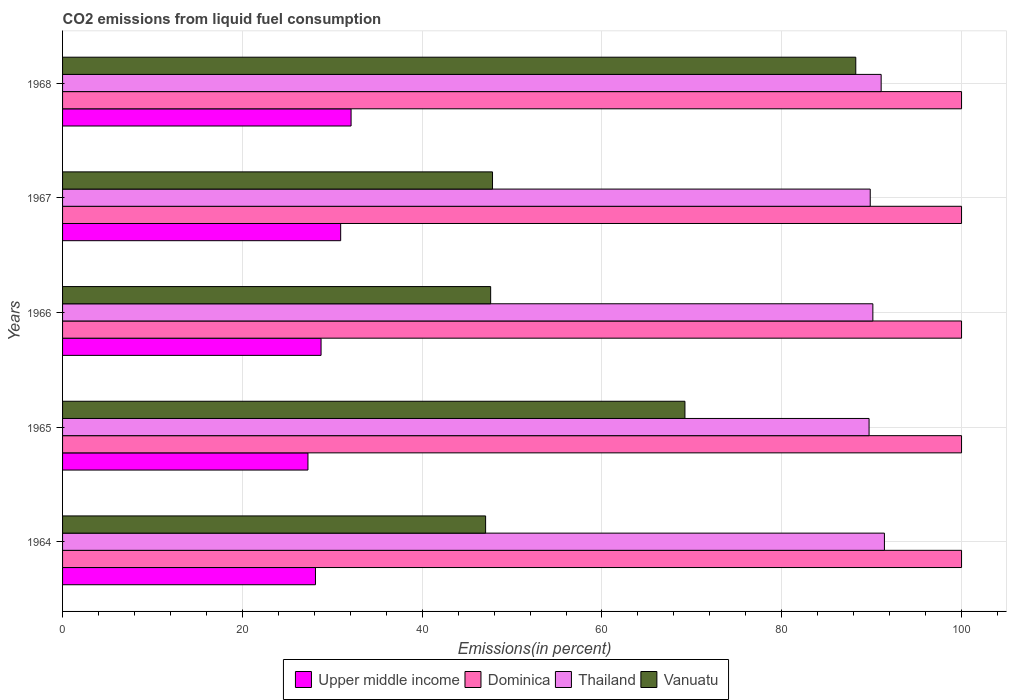Are the number of bars per tick equal to the number of legend labels?
Your response must be concise. Yes. How many bars are there on the 3rd tick from the bottom?
Offer a terse response. 4. What is the label of the 2nd group of bars from the top?
Make the answer very short. 1967. In how many cases, is the number of bars for a given year not equal to the number of legend labels?
Keep it short and to the point. 0. What is the total CO2 emitted in Upper middle income in 1968?
Offer a very short reply. 32.09. Across all years, what is the maximum total CO2 emitted in Upper middle income?
Your answer should be very brief. 32.09. Across all years, what is the minimum total CO2 emitted in Dominica?
Your answer should be compact. 100. In which year was the total CO2 emitted in Dominica maximum?
Provide a succinct answer. 1964. In which year was the total CO2 emitted in Dominica minimum?
Offer a very short reply. 1964. What is the total total CO2 emitted in Thailand in the graph?
Give a very brief answer. 452.17. What is the difference between the total CO2 emitted in Upper middle income in 1966 and that in 1967?
Provide a succinct answer. -2.18. What is the difference between the total CO2 emitted in Vanuatu in 1966 and the total CO2 emitted in Thailand in 1967?
Give a very brief answer. -42.22. What is the average total CO2 emitted in Dominica per year?
Provide a succinct answer. 100. In the year 1966, what is the difference between the total CO2 emitted in Thailand and total CO2 emitted in Dominica?
Keep it short and to the point. -9.86. What is the ratio of the total CO2 emitted in Thailand in 1965 to that in 1966?
Offer a terse response. 1. Is the total CO2 emitted in Dominica in 1964 less than that in 1968?
Your response must be concise. No. Is the difference between the total CO2 emitted in Thailand in 1964 and 1967 greater than the difference between the total CO2 emitted in Dominica in 1964 and 1967?
Give a very brief answer. Yes. What is the difference between the highest and the second highest total CO2 emitted in Upper middle income?
Provide a short and direct response. 1.16. What is the difference between the highest and the lowest total CO2 emitted in Thailand?
Provide a succinct answer. 1.71. What does the 4th bar from the top in 1965 represents?
Your answer should be very brief. Upper middle income. What does the 4th bar from the bottom in 1964 represents?
Provide a short and direct response. Vanuatu. Is it the case that in every year, the sum of the total CO2 emitted in Thailand and total CO2 emitted in Vanuatu is greater than the total CO2 emitted in Upper middle income?
Offer a very short reply. Yes. Are all the bars in the graph horizontal?
Provide a succinct answer. Yes. Are the values on the major ticks of X-axis written in scientific E-notation?
Make the answer very short. No. Does the graph contain any zero values?
Make the answer very short. No. Does the graph contain grids?
Provide a succinct answer. Yes. Where does the legend appear in the graph?
Provide a short and direct response. Bottom center. How many legend labels are there?
Offer a terse response. 4. How are the legend labels stacked?
Offer a very short reply. Horizontal. What is the title of the graph?
Keep it short and to the point. CO2 emissions from liquid fuel consumption. What is the label or title of the X-axis?
Provide a short and direct response. Emissions(in percent). What is the Emissions(in percent) in Upper middle income in 1964?
Offer a very short reply. 28.13. What is the Emissions(in percent) in Thailand in 1964?
Provide a succinct answer. 91.42. What is the Emissions(in percent) in Vanuatu in 1964?
Make the answer very short. 47.06. What is the Emissions(in percent) of Upper middle income in 1965?
Keep it short and to the point. 27.3. What is the Emissions(in percent) of Dominica in 1965?
Your answer should be compact. 100. What is the Emissions(in percent) of Thailand in 1965?
Make the answer very short. 89.71. What is the Emissions(in percent) of Vanuatu in 1965?
Ensure brevity in your answer.  69.23. What is the Emissions(in percent) of Upper middle income in 1966?
Your answer should be very brief. 28.75. What is the Emissions(in percent) of Dominica in 1966?
Provide a succinct answer. 100. What is the Emissions(in percent) of Thailand in 1966?
Provide a succinct answer. 90.14. What is the Emissions(in percent) of Vanuatu in 1966?
Provide a short and direct response. 47.62. What is the Emissions(in percent) of Upper middle income in 1967?
Provide a succinct answer. 30.94. What is the Emissions(in percent) of Thailand in 1967?
Give a very brief answer. 89.84. What is the Emissions(in percent) in Vanuatu in 1967?
Keep it short and to the point. 47.83. What is the Emissions(in percent) of Upper middle income in 1968?
Ensure brevity in your answer.  32.09. What is the Emissions(in percent) in Dominica in 1968?
Your response must be concise. 100. What is the Emissions(in percent) of Thailand in 1968?
Keep it short and to the point. 91.06. What is the Emissions(in percent) in Vanuatu in 1968?
Offer a terse response. 88.24. Across all years, what is the maximum Emissions(in percent) in Upper middle income?
Make the answer very short. 32.09. Across all years, what is the maximum Emissions(in percent) of Dominica?
Provide a succinct answer. 100. Across all years, what is the maximum Emissions(in percent) of Thailand?
Ensure brevity in your answer.  91.42. Across all years, what is the maximum Emissions(in percent) of Vanuatu?
Offer a very short reply. 88.24. Across all years, what is the minimum Emissions(in percent) in Upper middle income?
Provide a succinct answer. 27.3. Across all years, what is the minimum Emissions(in percent) in Thailand?
Your answer should be very brief. 89.71. Across all years, what is the minimum Emissions(in percent) of Vanuatu?
Ensure brevity in your answer.  47.06. What is the total Emissions(in percent) in Upper middle income in the graph?
Your answer should be compact. 147.21. What is the total Emissions(in percent) in Dominica in the graph?
Offer a very short reply. 500. What is the total Emissions(in percent) in Thailand in the graph?
Offer a very short reply. 452.17. What is the total Emissions(in percent) in Vanuatu in the graph?
Make the answer very short. 299.97. What is the difference between the Emissions(in percent) in Upper middle income in 1964 and that in 1965?
Your response must be concise. 0.84. What is the difference between the Emissions(in percent) of Thailand in 1964 and that in 1965?
Your answer should be very brief. 1.71. What is the difference between the Emissions(in percent) of Vanuatu in 1964 and that in 1965?
Give a very brief answer. -22.17. What is the difference between the Emissions(in percent) of Upper middle income in 1964 and that in 1966?
Give a very brief answer. -0.62. What is the difference between the Emissions(in percent) in Dominica in 1964 and that in 1966?
Provide a succinct answer. 0. What is the difference between the Emissions(in percent) in Thailand in 1964 and that in 1966?
Offer a very short reply. 1.29. What is the difference between the Emissions(in percent) in Vanuatu in 1964 and that in 1966?
Your answer should be very brief. -0.56. What is the difference between the Emissions(in percent) of Upper middle income in 1964 and that in 1967?
Make the answer very short. -2.8. What is the difference between the Emissions(in percent) of Dominica in 1964 and that in 1967?
Offer a very short reply. 0. What is the difference between the Emissions(in percent) of Thailand in 1964 and that in 1967?
Offer a very short reply. 1.58. What is the difference between the Emissions(in percent) of Vanuatu in 1964 and that in 1967?
Offer a terse response. -0.77. What is the difference between the Emissions(in percent) in Upper middle income in 1964 and that in 1968?
Give a very brief answer. -3.96. What is the difference between the Emissions(in percent) of Dominica in 1964 and that in 1968?
Ensure brevity in your answer.  0. What is the difference between the Emissions(in percent) in Thailand in 1964 and that in 1968?
Give a very brief answer. 0.36. What is the difference between the Emissions(in percent) in Vanuatu in 1964 and that in 1968?
Make the answer very short. -41.18. What is the difference between the Emissions(in percent) of Upper middle income in 1965 and that in 1966?
Ensure brevity in your answer.  -1.46. What is the difference between the Emissions(in percent) in Thailand in 1965 and that in 1966?
Provide a succinct answer. -0.42. What is the difference between the Emissions(in percent) in Vanuatu in 1965 and that in 1966?
Offer a terse response. 21.61. What is the difference between the Emissions(in percent) in Upper middle income in 1965 and that in 1967?
Provide a short and direct response. -3.64. What is the difference between the Emissions(in percent) in Dominica in 1965 and that in 1967?
Your response must be concise. 0. What is the difference between the Emissions(in percent) in Thailand in 1965 and that in 1967?
Make the answer very short. -0.13. What is the difference between the Emissions(in percent) of Vanuatu in 1965 and that in 1967?
Offer a terse response. 21.4. What is the difference between the Emissions(in percent) in Upper middle income in 1965 and that in 1968?
Your answer should be compact. -4.8. What is the difference between the Emissions(in percent) of Dominica in 1965 and that in 1968?
Provide a short and direct response. 0. What is the difference between the Emissions(in percent) in Thailand in 1965 and that in 1968?
Offer a very short reply. -1.34. What is the difference between the Emissions(in percent) in Vanuatu in 1965 and that in 1968?
Offer a very short reply. -19. What is the difference between the Emissions(in percent) of Upper middle income in 1966 and that in 1967?
Offer a very short reply. -2.18. What is the difference between the Emissions(in percent) of Dominica in 1966 and that in 1967?
Offer a very short reply. 0. What is the difference between the Emissions(in percent) in Thailand in 1966 and that in 1967?
Your response must be concise. 0.29. What is the difference between the Emissions(in percent) of Vanuatu in 1966 and that in 1967?
Provide a succinct answer. -0.21. What is the difference between the Emissions(in percent) in Upper middle income in 1966 and that in 1968?
Make the answer very short. -3.34. What is the difference between the Emissions(in percent) in Thailand in 1966 and that in 1968?
Ensure brevity in your answer.  -0.92. What is the difference between the Emissions(in percent) of Vanuatu in 1966 and that in 1968?
Ensure brevity in your answer.  -40.62. What is the difference between the Emissions(in percent) in Upper middle income in 1967 and that in 1968?
Your answer should be very brief. -1.16. What is the difference between the Emissions(in percent) in Thailand in 1967 and that in 1968?
Ensure brevity in your answer.  -1.21. What is the difference between the Emissions(in percent) of Vanuatu in 1967 and that in 1968?
Your answer should be compact. -40.41. What is the difference between the Emissions(in percent) in Upper middle income in 1964 and the Emissions(in percent) in Dominica in 1965?
Provide a short and direct response. -71.87. What is the difference between the Emissions(in percent) of Upper middle income in 1964 and the Emissions(in percent) of Thailand in 1965?
Offer a terse response. -61.58. What is the difference between the Emissions(in percent) of Upper middle income in 1964 and the Emissions(in percent) of Vanuatu in 1965?
Your answer should be very brief. -41.1. What is the difference between the Emissions(in percent) in Dominica in 1964 and the Emissions(in percent) in Thailand in 1965?
Give a very brief answer. 10.29. What is the difference between the Emissions(in percent) in Dominica in 1964 and the Emissions(in percent) in Vanuatu in 1965?
Provide a short and direct response. 30.77. What is the difference between the Emissions(in percent) of Thailand in 1964 and the Emissions(in percent) of Vanuatu in 1965?
Keep it short and to the point. 22.19. What is the difference between the Emissions(in percent) in Upper middle income in 1964 and the Emissions(in percent) in Dominica in 1966?
Give a very brief answer. -71.87. What is the difference between the Emissions(in percent) of Upper middle income in 1964 and the Emissions(in percent) of Thailand in 1966?
Your answer should be very brief. -62. What is the difference between the Emissions(in percent) of Upper middle income in 1964 and the Emissions(in percent) of Vanuatu in 1966?
Keep it short and to the point. -19.49. What is the difference between the Emissions(in percent) of Dominica in 1964 and the Emissions(in percent) of Thailand in 1966?
Make the answer very short. 9.86. What is the difference between the Emissions(in percent) in Dominica in 1964 and the Emissions(in percent) in Vanuatu in 1966?
Give a very brief answer. 52.38. What is the difference between the Emissions(in percent) of Thailand in 1964 and the Emissions(in percent) of Vanuatu in 1966?
Keep it short and to the point. 43.8. What is the difference between the Emissions(in percent) in Upper middle income in 1964 and the Emissions(in percent) in Dominica in 1967?
Give a very brief answer. -71.87. What is the difference between the Emissions(in percent) of Upper middle income in 1964 and the Emissions(in percent) of Thailand in 1967?
Keep it short and to the point. -61.71. What is the difference between the Emissions(in percent) in Upper middle income in 1964 and the Emissions(in percent) in Vanuatu in 1967?
Your response must be concise. -19.69. What is the difference between the Emissions(in percent) of Dominica in 1964 and the Emissions(in percent) of Thailand in 1967?
Ensure brevity in your answer.  10.16. What is the difference between the Emissions(in percent) of Dominica in 1964 and the Emissions(in percent) of Vanuatu in 1967?
Give a very brief answer. 52.17. What is the difference between the Emissions(in percent) of Thailand in 1964 and the Emissions(in percent) of Vanuatu in 1967?
Keep it short and to the point. 43.6. What is the difference between the Emissions(in percent) in Upper middle income in 1964 and the Emissions(in percent) in Dominica in 1968?
Your answer should be compact. -71.87. What is the difference between the Emissions(in percent) in Upper middle income in 1964 and the Emissions(in percent) in Thailand in 1968?
Your response must be concise. -62.92. What is the difference between the Emissions(in percent) of Upper middle income in 1964 and the Emissions(in percent) of Vanuatu in 1968?
Provide a short and direct response. -60.1. What is the difference between the Emissions(in percent) in Dominica in 1964 and the Emissions(in percent) in Thailand in 1968?
Keep it short and to the point. 8.94. What is the difference between the Emissions(in percent) of Dominica in 1964 and the Emissions(in percent) of Vanuatu in 1968?
Make the answer very short. 11.76. What is the difference between the Emissions(in percent) of Thailand in 1964 and the Emissions(in percent) of Vanuatu in 1968?
Your response must be concise. 3.19. What is the difference between the Emissions(in percent) in Upper middle income in 1965 and the Emissions(in percent) in Dominica in 1966?
Offer a terse response. -72.7. What is the difference between the Emissions(in percent) of Upper middle income in 1965 and the Emissions(in percent) of Thailand in 1966?
Offer a terse response. -62.84. What is the difference between the Emissions(in percent) in Upper middle income in 1965 and the Emissions(in percent) in Vanuatu in 1966?
Your answer should be compact. -20.32. What is the difference between the Emissions(in percent) in Dominica in 1965 and the Emissions(in percent) in Thailand in 1966?
Make the answer very short. 9.86. What is the difference between the Emissions(in percent) of Dominica in 1965 and the Emissions(in percent) of Vanuatu in 1966?
Provide a short and direct response. 52.38. What is the difference between the Emissions(in percent) in Thailand in 1965 and the Emissions(in percent) in Vanuatu in 1966?
Your answer should be very brief. 42.1. What is the difference between the Emissions(in percent) of Upper middle income in 1965 and the Emissions(in percent) of Dominica in 1967?
Your response must be concise. -72.7. What is the difference between the Emissions(in percent) of Upper middle income in 1965 and the Emissions(in percent) of Thailand in 1967?
Offer a terse response. -62.55. What is the difference between the Emissions(in percent) in Upper middle income in 1965 and the Emissions(in percent) in Vanuatu in 1967?
Ensure brevity in your answer.  -20.53. What is the difference between the Emissions(in percent) in Dominica in 1965 and the Emissions(in percent) in Thailand in 1967?
Your response must be concise. 10.16. What is the difference between the Emissions(in percent) of Dominica in 1965 and the Emissions(in percent) of Vanuatu in 1967?
Provide a succinct answer. 52.17. What is the difference between the Emissions(in percent) of Thailand in 1965 and the Emissions(in percent) of Vanuatu in 1967?
Your response must be concise. 41.89. What is the difference between the Emissions(in percent) of Upper middle income in 1965 and the Emissions(in percent) of Dominica in 1968?
Give a very brief answer. -72.7. What is the difference between the Emissions(in percent) in Upper middle income in 1965 and the Emissions(in percent) in Thailand in 1968?
Ensure brevity in your answer.  -63.76. What is the difference between the Emissions(in percent) of Upper middle income in 1965 and the Emissions(in percent) of Vanuatu in 1968?
Provide a succinct answer. -60.94. What is the difference between the Emissions(in percent) in Dominica in 1965 and the Emissions(in percent) in Thailand in 1968?
Make the answer very short. 8.94. What is the difference between the Emissions(in percent) in Dominica in 1965 and the Emissions(in percent) in Vanuatu in 1968?
Give a very brief answer. 11.76. What is the difference between the Emissions(in percent) of Thailand in 1965 and the Emissions(in percent) of Vanuatu in 1968?
Provide a short and direct response. 1.48. What is the difference between the Emissions(in percent) of Upper middle income in 1966 and the Emissions(in percent) of Dominica in 1967?
Your answer should be compact. -71.25. What is the difference between the Emissions(in percent) of Upper middle income in 1966 and the Emissions(in percent) of Thailand in 1967?
Your answer should be compact. -61.09. What is the difference between the Emissions(in percent) of Upper middle income in 1966 and the Emissions(in percent) of Vanuatu in 1967?
Your answer should be very brief. -19.07. What is the difference between the Emissions(in percent) in Dominica in 1966 and the Emissions(in percent) in Thailand in 1967?
Offer a terse response. 10.16. What is the difference between the Emissions(in percent) of Dominica in 1966 and the Emissions(in percent) of Vanuatu in 1967?
Make the answer very short. 52.17. What is the difference between the Emissions(in percent) of Thailand in 1966 and the Emissions(in percent) of Vanuatu in 1967?
Keep it short and to the point. 42.31. What is the difference between the Emissions(in percent) in Upper middle income in 1966 and the Emissions(in percent) in Dominica in 1968?
Offer a very short reply. -71.25. What is the difference between the Emissions(in percent) of Upper middle income in 1966 and the Emissions(in percent) of Thailand in 1968?
Your answer should be compact. -62.3. What is the difference between the Emissions(in percent) in Upper middle income in 1966 and the Emissions(in percent) in Vanuatu in 1968?
Your response must be concise. -59.48. What is the difference between the Emissions(in percent) of Dominica in 1966 and the Emissions(in percent) of Thailand in 1968?
Offer a terse response. 8.94. What is the difference between the Emissions(in percent) of Dominica in 1966 and the Emissions(in percent) of Vanuatu in 1968?
Provide a short and direct response. 11.76. What is the difference between the Emissions(in percent) of Thailand in 1966 and the Emissions(in percent) of Vanuatu in 1968?
Ensure brevity in your answer.  1.9. What is the difference between the Emissions(in percent) of Upper middle income in 1967 and the Emissions(in percent) of Dominica in 1968?
Your response must be concise. -69.06. What is the difference between the Emissions(in percent) in Upper middle income in 1967 and the Emissions(in percent) in Thailand in 1968?
Offer a very short reply. -60.12. What is the difference between the Emissions(in percent) of Upper middle income in 1967 and the Emissions(in percent) of Vanuatu in 1968?
Your answer should be very brief. -57.3. What is the difference between the Emissions(in percent) in Dominica in 1967 and the Emissions(in percent) in Thailand in 1968?
Keep it short and to the point. 8.94. What is the difference between the Emissions(in percent) of Dominica in 1967 and the Emissions(in percent) of Vanuatu in 1968?
Offer a very short reply. 11.76. What is the difference between the Emissions(in percent) in Thailand in 1967 and the Emissions(in percent) in Vanuatu in 1968?
Provide a succinct answer. 1.61. What is the average Emissions(in percent) in Upper middle income per year?
Ensure brevity in your answer.  29.44. What is the average Emissions(in percent) of Thailand per year?
Your answer should be very brief. 90.43. What is the average Emissions(in percent) in Vanuatu per year?
Provide a succinct answer. 59.99. In the year 1964, what is the difference between the Emissions(in percent) of Upper middle income and Emissions(in percent) of Dominica?
Provide a succinct answer. -71.87. In the year 1964, what is the difference between the Emissions(in percent) in Upper middle income and Emissions(in percent) in Thailand?
Your response must be concise. -63.29. In the year 1964, what is the difference between the Emissions(in percent) in Upper middle income and Emissions(in percent) in Vanuatu?
Make the answer very short. -18.93. In the year 1964, what is the difference between the Emissions(in percent) in Dominica and Emissions(in percent) in Thailand?
Your answer should be very brief. 8.58. In the year 1964, what is the difference between the Emissions(in percent) of Dominica and Emissions(in percent) of Vanuatu?
Your answer should be compact. 52.94. In the year 1964, what is the difference between the Emissions(in percent) of Thailand and Emissions(in percent) of Vanuatu?
Make the answer very short. 44.36. In the year 1965, what is the difference between the Emissions(in percent) in Upper middle income and Emissions(in percent) in Dominica?
Provide a succinct answer. -72.7. In the year 1965, what is the difference between the Emissions(in percent) of Upper middle income and Emissions(in percent) of Thailand?
Ensure brevity in your answer.  -62.42. In the year 1965, what is the difference between the Emissions(in percent) of Upper middle income and Emissions(in percent) of Vanuatu?
Offer a very short reply. -41.93. In the year 1965, what is the difference between the Emissions(in percent) in Dominica and Emissions(in percent) in Thailand?
Offer a very short reply. 10.29. In the year 1965, what is the difference between the Emissions(in percent) of Dominica and Emissions(in percent) of Vanuatu?
Give a very brief answer. 30.77. In the year 1965, what is the difference between the Emissions(in percent) in Thailand and Emissions(in percent) in Vanuatu?
Offer a very short reply. 20.48. In the year 1966, what is the difference between the Emissions(in percent) of Upper middle income and Emissions(in percent) of Dominica?
Your answer should be very brief. -71.25. In the year 1966, what is the difference between the Emissions(in percent) of Upper middle income and Emissions(in percent) of Thailand?
Provide a succinct answer. -61.38. In the year 1966, what is the difference between the Emissions(in percent) of Upper middle income and Emissions(in percent) of Vanuatu?
Ensure brevity in your answer.  -18.87. In the year 1966, what is the difference between the Emissions(in percent) in Dominica and Emissions(in percent) in Thailand?
Provide a succinct answer. 9.86. In the year 1966, what is the difference between the Emissions(in percent) of Dominica and Emissions(in percent) of Vanuatu?
Your response must be concise. 52.38. In the year 1966, what is the difference between the Emissions(in percent) of Thailand and Emissions(in percent) of Vanuatu?
Give a very brief answer. 42.52. In the year 1967, what is the difference between the Emissions(in percent) in Upper middle income and Emissions(in percent) in Dominica?
Give a very brief answer. -69.06. In the year 1967, what is the difference between the Emissions(in percent) in Upper middle income and Emissions(in percent) in Thailand?
Keep it short and to the point. -58.91. In the year 1967, what is the difference between the Emissions(in percent) of Upper middle income and Emissions(in percent) of Vanuatu?
Your answer should be compact. -16.89. In the year 1967, what is the difference between the Emissions(in percent) of Dominica and Emissions(in percent) of Thailand?
Your answer should be very brief. 10.16. In the year 1967, what is the difference between the Emissions(in percent) of Dominica and Emissions(in percent) of Vanuatu?
Your response must be concise. 52.17. In the year 1967, what is the difference between the Emissions(in percent) in Thailand and Emissions(in percent) in Vanuatu?
Ensure brevity in your answer.  42.02. In the year 1968, what is the difference between the Emissions(in percent) in Upper middle income and Emissions(in percent) in Dominica?
Your answer should be very brief. -67.91. In the year 1968, what is the difference between the Emissions(in percent) of Upper middle income and Emissions(in percent) of Thailand?
Give a very brief answer. -58.96. In the year 1968, what is the difference between the Emissions(in percent) in Upper middle income and Emissions(in percent) in Vanuatu?
Offer a very short reply. -56.14. In the year 1968, what is the difference between the Emissions(in percent) of Dominica and Emissions(in percent) of Thailand?
Provide a succinct answer. 8.94. In the year 1968, what is the difference between the Emissions(in percent) in Dominica and Emissions(in percent) in Vanuatu?
Give a very brief answer. 11.76. In the year 1968, what is the difference between the Emissions(in percent) of Thailand and Emissions(in percent) of Vanuatu?
Make the answer very short. 2.82. What is the ratio of the Emissions(in percent) of Upper middle income in 1964 to that in 1965?
Your response must be concise. 1.03. What is the ratio of the Emissions(in percent) in Dominica in 1964 to that in 1965?
Your answer should be compact. 1. What is the ratio of the Emissions(in percent) of Vanuatu in 1964 to that in 1965?
Ensure brevity in your answer.  0.68. What is the ratio of the Emissions(in percent) in Upper middle income in 1964 to that in 1966?
Keep it short and to the point. 0.98. What is the ratio of the Emissions(in percent) of Dominica in 1964 to that in 1966?
Your response must be concise. 1. What is the ratio of the Emissions(in percent) in Thailand in 1964 to that in 1966?
Your response must be concise. 1.01. What is the ratio of the Emissions(in percent) in Vanuatu in 1964 to that in 1966?
Give a very brief answer. 0.99. What is the ratio of the Emissions(in percent) in Upper middle income in 1964 to that in 1967?
Ensure brevity in your answer.  0.91. What is the ratio of the Emissions(in percent) of Dominica in 1964 to that in 1967?
Provide a short and direct response. 1. What is the ratio of the Emissions(in percent) in Thailand in 1964 to that in 1967?
Keep it short and to the point. 1.02. What is the ratio of the Emissions(in percent) in Vanuatu in 1964 to that in 1967?
Provide a succinct answer. 0.98. What is the ratio of the Emissions(in percent) in Upper middle income in 1964 to that in 1968?
Give a very brief answer. 0.88. What is the ratio of the Emissions(in percent) in Vanuatu in 1964 to that in 1968?
Your response must be concise. 0.53. What is the ratio of the Emissions(in percent) of Upper middle income in 1965 to that in 1966?
Provide a succinct answer. 0.95. What is the ratio of the Emissions(in percent) of Vanuatu in 1965 to that in 1966?
Ensure brevity in your answer.  1.45. What is the ratio of the Emissions(in percent) of Upper middle income in 1965 to that in 1967?
Your response must be concise. 0.88. What is the ratio of the Emissions(in percent) of Dominica in 1965 to that in 1967?
Give a very brief answer. 1. What is the ratio of the Emissions(in percent) in Vanuatu in 1965 to that in 1967?
Keep it short and to the point. 1.45. What is the ratio of the Emissions(in percent) of Upper middle income in 1965 to that in 1968?
Your answer should be very brief. 0.85. What is the ratio of the Emissions(in percent) in Vanuatu in 1965 to that in 1968?
Keep it short and to the point. 0.78. What is the ratio of the Emissions(in percent) in Upper middle income in 1966 to that in 1967?
Your answer should be compact. 0.93. What is the ratio of the Emissions(in percent) in Dominica in 1966 to that in 1967?
Offer a terse response. 1. What is the ratio of the Emissions(in percent) of Vanuatu in 1966 to that in 1967?
Ensure brevity in your answer.  1. What is the ratio of the Emissions(in percent) of Upper middle income in 1966 to that in 1968?
Your answer should be very brief. 0.9. What is the ratio of the Emissions(in percent) of Dominica in 1966 to that in 1968?
Your answer should be very brief. 1. What is the ratio of the Emissions(in percent) of Thailand in 1966 to that in 1968?
Ensure brevity in your answer.  0.99. What is the ratio of the Emissions(in percent) of Vanuatu in 1966 to that in 1968?
Keep it short and to the point. 0.54. What is the ratio of the Emissions(in percent) of Upper middle income in 1967 to that in 1968?
Provide a short and direct response. 0.96. What is the ratio of the Emissions(in percent) of Thailand in 1967 to that in 1968?
Your answer should be very brief. 0.99. What is the ratio of the Emissions(in percent) of Vanuatu in 1967 to that in 1968?
Your response must be concise. 0.54. What is the difference between the highest and the second highest Emissions(in percent) in Upper middle income?
Your answer should be very brief. 1.16. What is the difference between the highest and the second highest Emissions(in percent) in Dominica?
Offer a terse response. 0. What is the difference between the highest and the second highest Emissions(in percent) of Thailand?
Ensure brevity in your answer.  0.36. What is the difference between the highest and the second highest Emissions(in percent) of Vanuatu?
Give a very brief answer. 19. What is the difference between the highest and the lowest Emissions(in percent) of Upper middle income?
Keep it short and to the point. 4.8. What is the difference between the highest and the lowest Emissions(in percent) in Dominica?
Your answer should be compact. 0. What is the difference between the highest and the lowest Emissions(in percent) of Thailand?
Keep it short and to the point. 1.71. What is the difference between the highest and the lowest Emissions(in percent) of Vanuatu?
Your response must be concise. 41.18. 